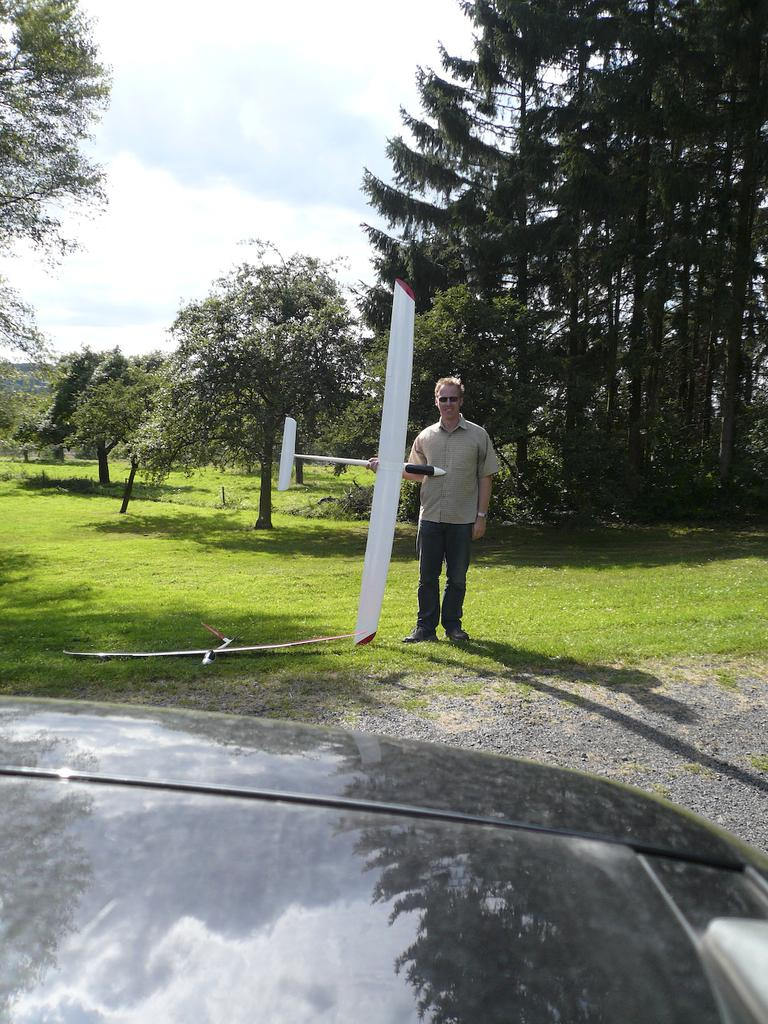What is the person in the image standing on? The person is standing on grass in the image. What else can be seen at the bottom of the image? There is a vehicle part visible at the bottom of the image. What is the person holding in the image? The person is holding an object in the image. What is visible at the top of the image? The sky is visible at the top of the image. What type of vegetation is present in the image? There are trees present in the image. What team does the actor belong to in the image? There is no actor present in the image, and therefore no team affiliation can be determined. 